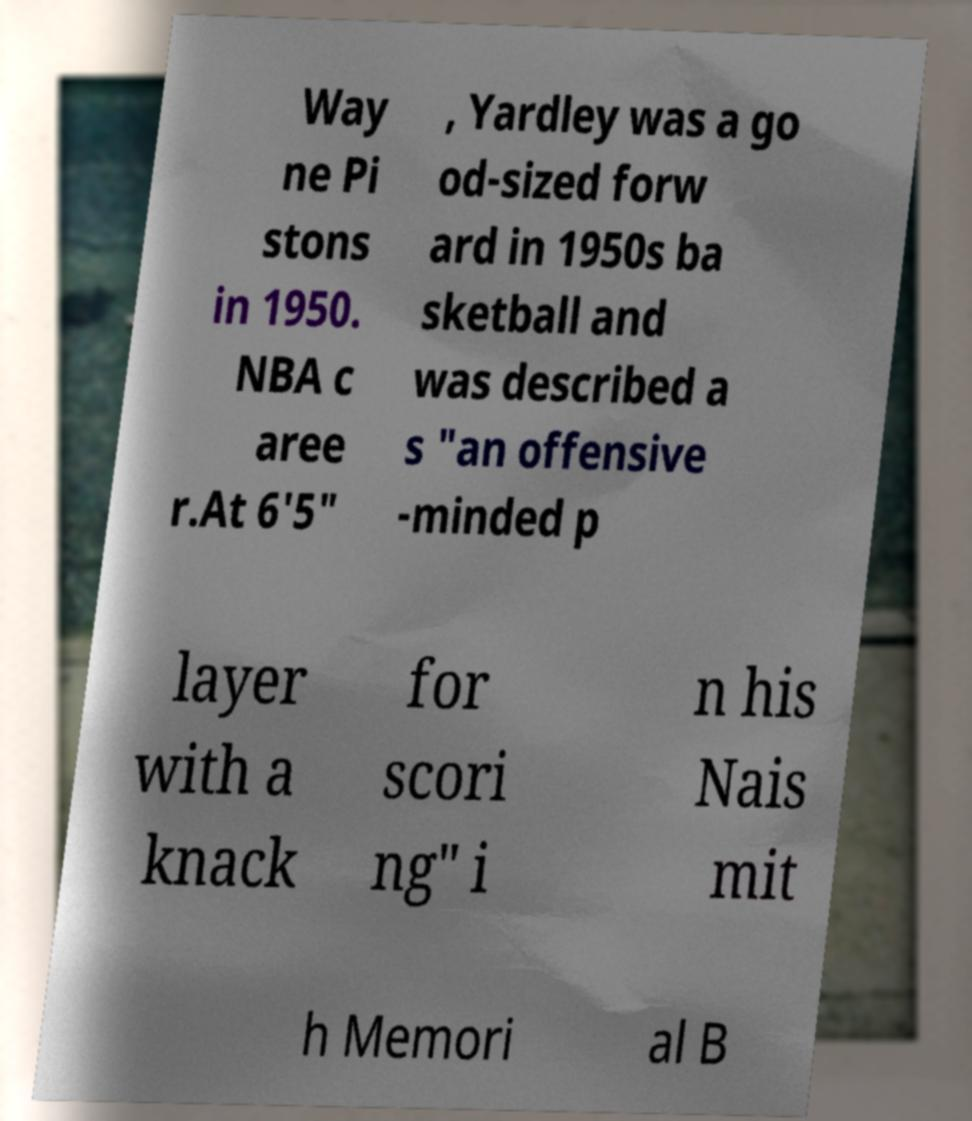For documentation purposes, I need the text within this image transcribed. Could you provide that? Way ne Pi stons in 1950. NBA c aree r.At 6'5" , Yardley was a go od-sized forw ard in 1950s ba sketball and was described a s "an offensive -minded p layer with a knack for scori ng" i n his Nais mit h Memori al B 